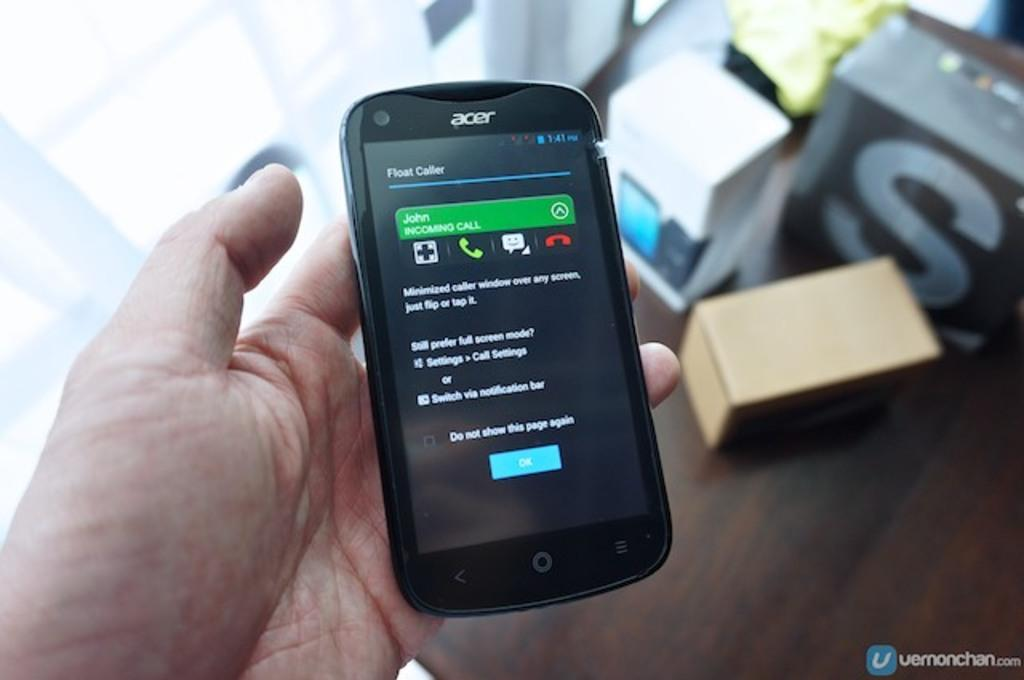Provide a one-sentence caption for the provided image. John is calling the owner of this Acer phone. 